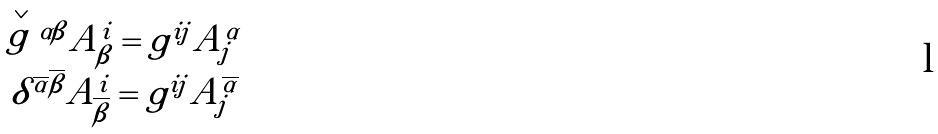Convert formula to latex. <formula><loc_0><loc_0><loc_500><loc_500>\begin{array} { c } \stackrel { \vee } { g } { ^ { \alpha \beta } } A _ { \beta } ^ { i } = g ^ { i j } A _ { j } ^ { \alpha } \\ \delta ^ { \overline { \alpha } \overline { \beta } } A _ { \overline { \beta } } ^ { i } = g ^ { i j } A _ { j } ^ { \overline { \alpha } } \end{array}</formula> 